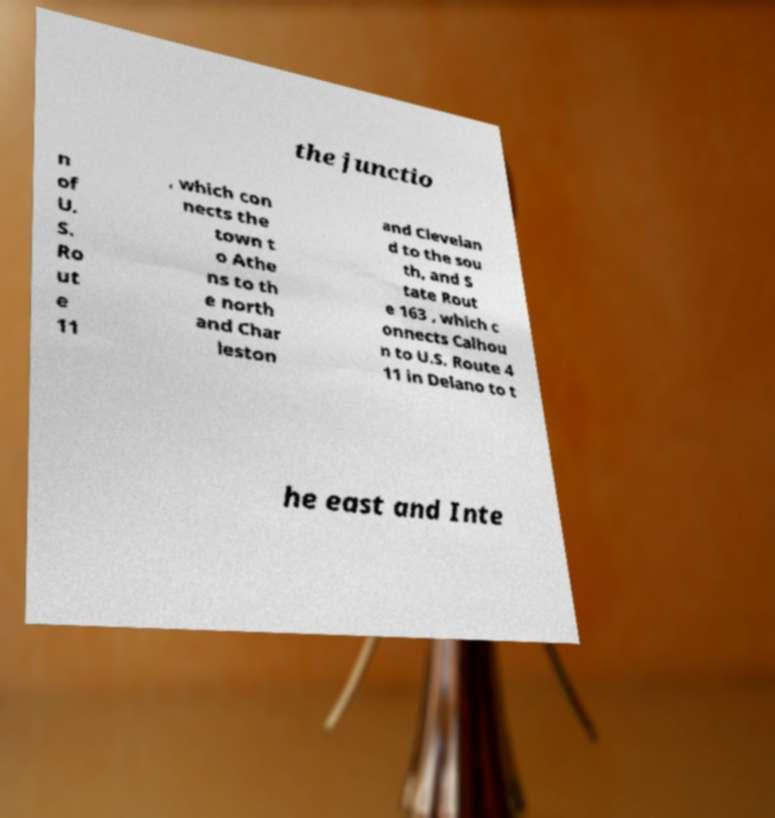I need the written content from this picture converted into text. Can you do that? the junctio n of U. S. Ro ut e 11 , which con nects the town t o Athe ns to th e north and Char leston and Clevelan d to the sou th, and S tate Rout e 163 , which c onnects Calhou n to U.S. Route 4 11 in Delano to t he east and Inte 